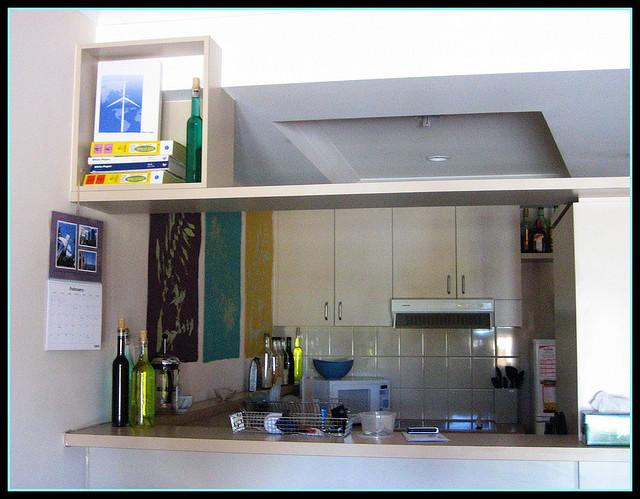Where are the telephone books?
Write a very short answer. On shelf. Can you see through the cabinet doors?
Be succinct. No. Is there a microwave in this kitchen?
Answer briefly. Yes. Is a window present in the picture shown?
Quick response, please. No. Is there a mirror in the kitchen?
Answer briefly. No. 